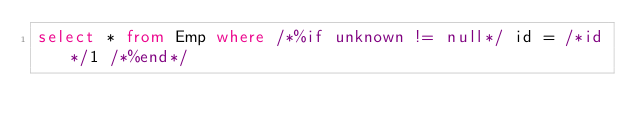<code> <loc_0><loc_0><loc_500><loc_500><_SQL_>select * from Emp where /*%if unknown != null*/ id = /*id*/1 /*%end*/</code> 